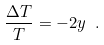<formula> <loc_0><loc_0><loc_500><loc_500>\frac { \Delta T } { T } = - 2 y \ .</formula> 